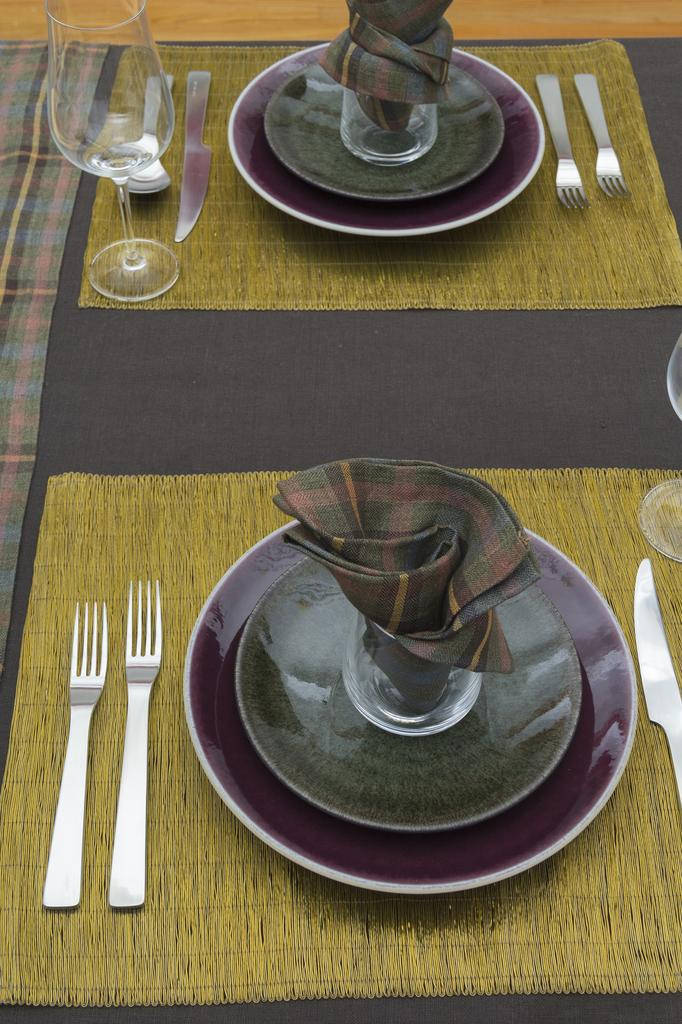What piece of furniture is present in the image? There is a table in the image. What is placed on the table? There are two plates on the table. What is inside the plates? There are two glasses in the plates. What utensils are beside the plates? There are forks and knives beside the plates. What else can be seen on the table? There are glasses on the table. What type of pie is being served on the table in the image? There is no pie present in the image; it only shows plates, glasses, and utensils on the table. 